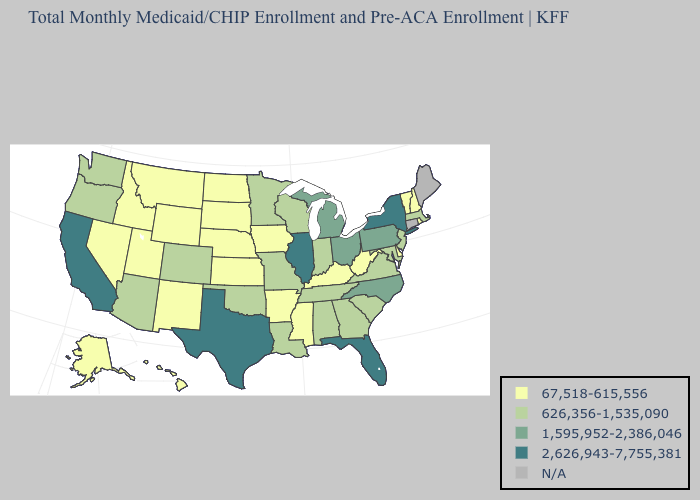What is the lowest value in the USA?
Give a very brief answer. 67,518-615,556. What is the value of Montana?
Quick response, please. 67,518-615,556. Does California have the highest value in the West?
Concise answer only. Yes. What is the lowest value in states that border Arkansas?
Be succinct. 67,518-615,556. Does California have the lowest value in the West?
Short answer required. No. Name the states that have a value in the range 2,626,943-7,755,381?
Concise answer only. California, Florida, Illinois, New York, Texas. What is the highest value in the USA?
Quick response, please. 2,626,943-7,755,381. Which states hav the highest value in the West?
Be succinct. California. What is the lowest value in the MidWest?
Write a very short answer. 67,518-615,556. What is the lowest value in the USA?
Quick response, please. 67,518-615,556. Among the states that border Louisiana , which have the lowest value?
Answer briefly. Arkansas, Mississippi. Name the states that have a value in the range 626,356-1,535,090?
Keep it brief. Alabama, Arizona, Colorado, Georgia, Indiana, Louisiana, Maryland, Massachusetts, Minnesota, Missouri, New Jersey, Oklahoma, Oregon, South Carolina, Tennessee, Virginia, Washington, Wisconsin. Which states hav the highest value in the MidWest?
Concise answer only. Illinois. Does Texas have the highest value in the USA?
Answer briefly. Yes. What is the value of Mississippi?
Be succinct. 67,518-615,556. 